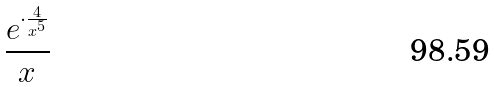<formula> <loc_0><loc_0><loc_500><loc_500>\frac { e ^ { \cdot \frac { 4 } { x ^ { 5 } } } } { x }</formula> 